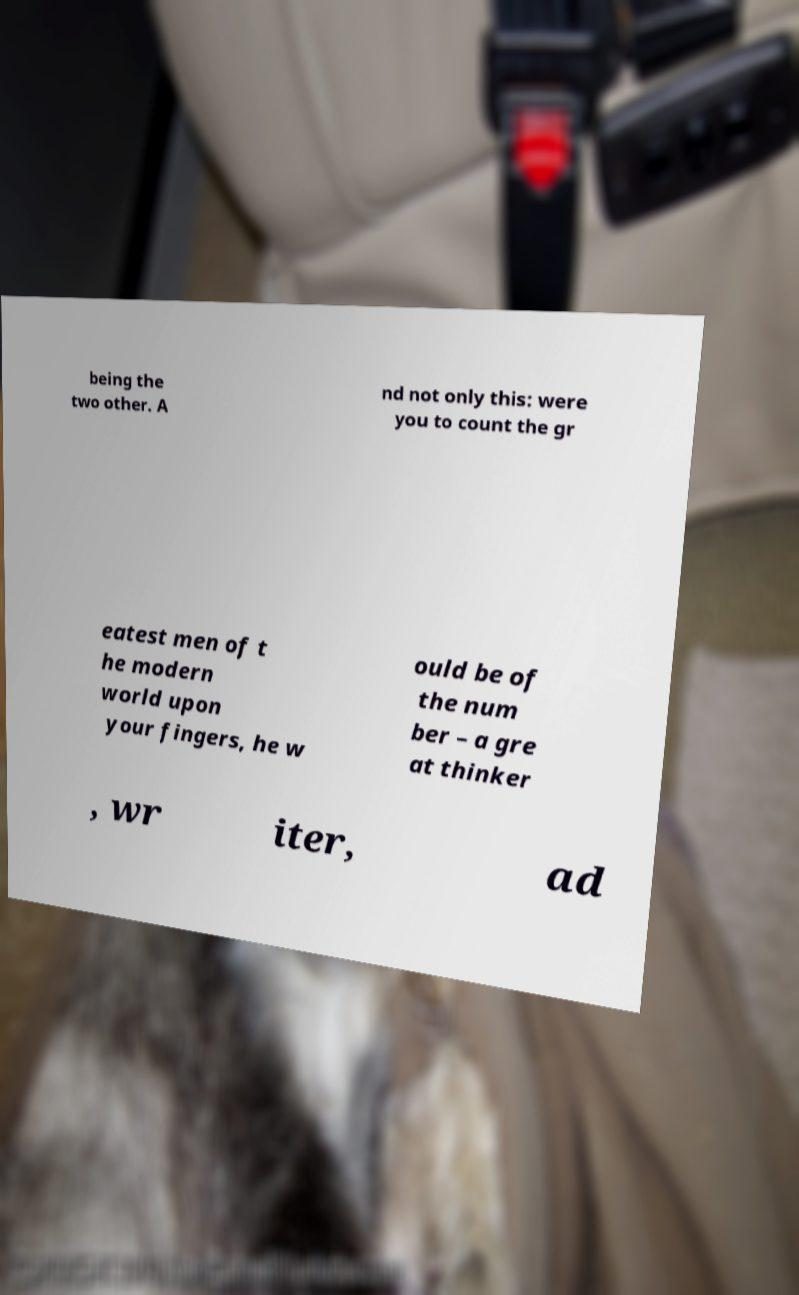Can you read and provide the text displayed in the image?This photo seems to have some interesting text. Can you extract and type it out for me? being the two other. A nd not only this: were you to count the gr eatest men of t he modern world upon your fingers, he w ould be of the num ber – a gre at thinker , wr iter, ad 